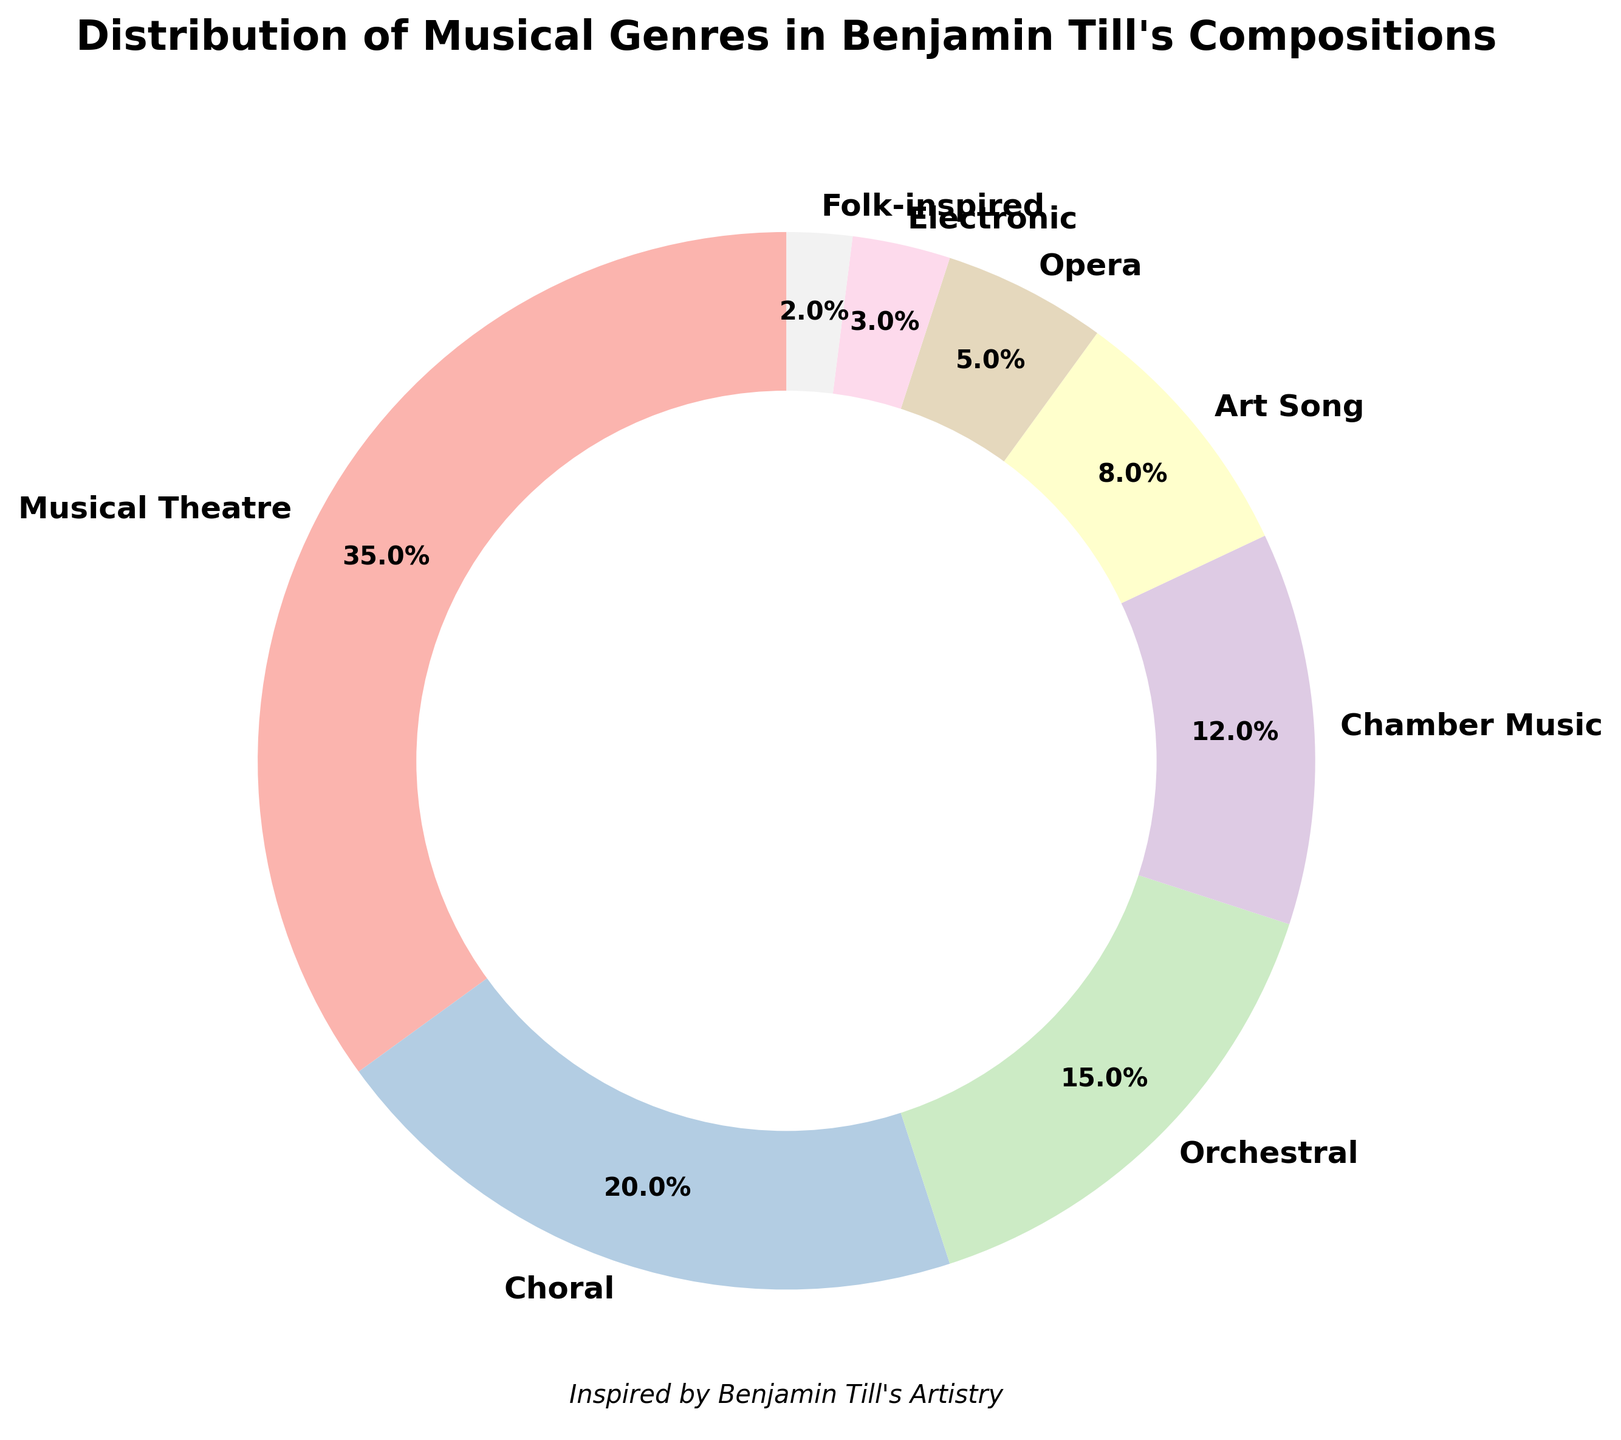Which genre has the largest portion in Benjamin Till's compositions? The figure shows various genres and their respective percentages. The genre with the highest percentage is Musical Theatre at 35%.
Answer: Musical Theatre How many genres have more than 10% representation in the compositional breakdown? By looking at the figure, we see that Musical Theatre (35%), Choral (20%), Orchestral (15%), and Chamber Music (12%) all have percentages greater than 10. There are 4 genres in total.
Answer: 4 What is the combined percentage of the three least represented genres? The least represented genres are Folk-inspired (2%), Electronic (3%), and Opera (5%). Adding these together gives 2% + 3% + 5% = 10%.
Answer: 10% Which genre has exactly one fifth the percentage of Musical Theatre compositions? Musical Theatre has 35%. To find the genre with one-fifth of this, calculate 35% / 5 = 7%. The genre with 8% is Art Song, which is close to but not exactly one-fifth of 35%. So no genre has exactly one-fifth the percentage of Musical Theatre.
Answer: None How does the percentage of Orchestral compositions compare to that of Choral compositions? The figure shows Orchestral compositions at 15% and Choral compositions at 20%. Orchestral is less than Choral by 20% - 15% = 5%.
Answer: Orchestral is 5% less If you combine the percentages of Choral and Chamber Music compositions, how does it compare to the percentage of Musical Theatre compositions? The percentages for Choral and Chamber Music are 20% and 12% respectively. Adding these gives 20% + 12% = 32%. Musical Theatre is 35%. Therefore, the combined percentage of Choral and Chamber Music is 3% less than Musical Theatre.
Answer: 3% less What is the average percentage of the bottom four genres? The bottom four genres are Art Song (8%), Opera (5%), Electronic (3%), and Folk-inspired (2%). The sum is 8% + 5% + 3% + 2% = 18%. The average is 18% / 4 = 4.5%.
Answer: 4.5% Which genre comprises more than the combined percentage of Art Song and Electronic compositions? Art Song is 8% and Electronic is 3%. Their combined percentage is 8% + 3% = 11%. Both Musical Theatre (35%), Choral (20%), Orchestral (15%), and Chamber Music (12%) are more than 11%.
Answer: 4 genres: Musical Theatre, Choral, Orchestral, Chamber Music 